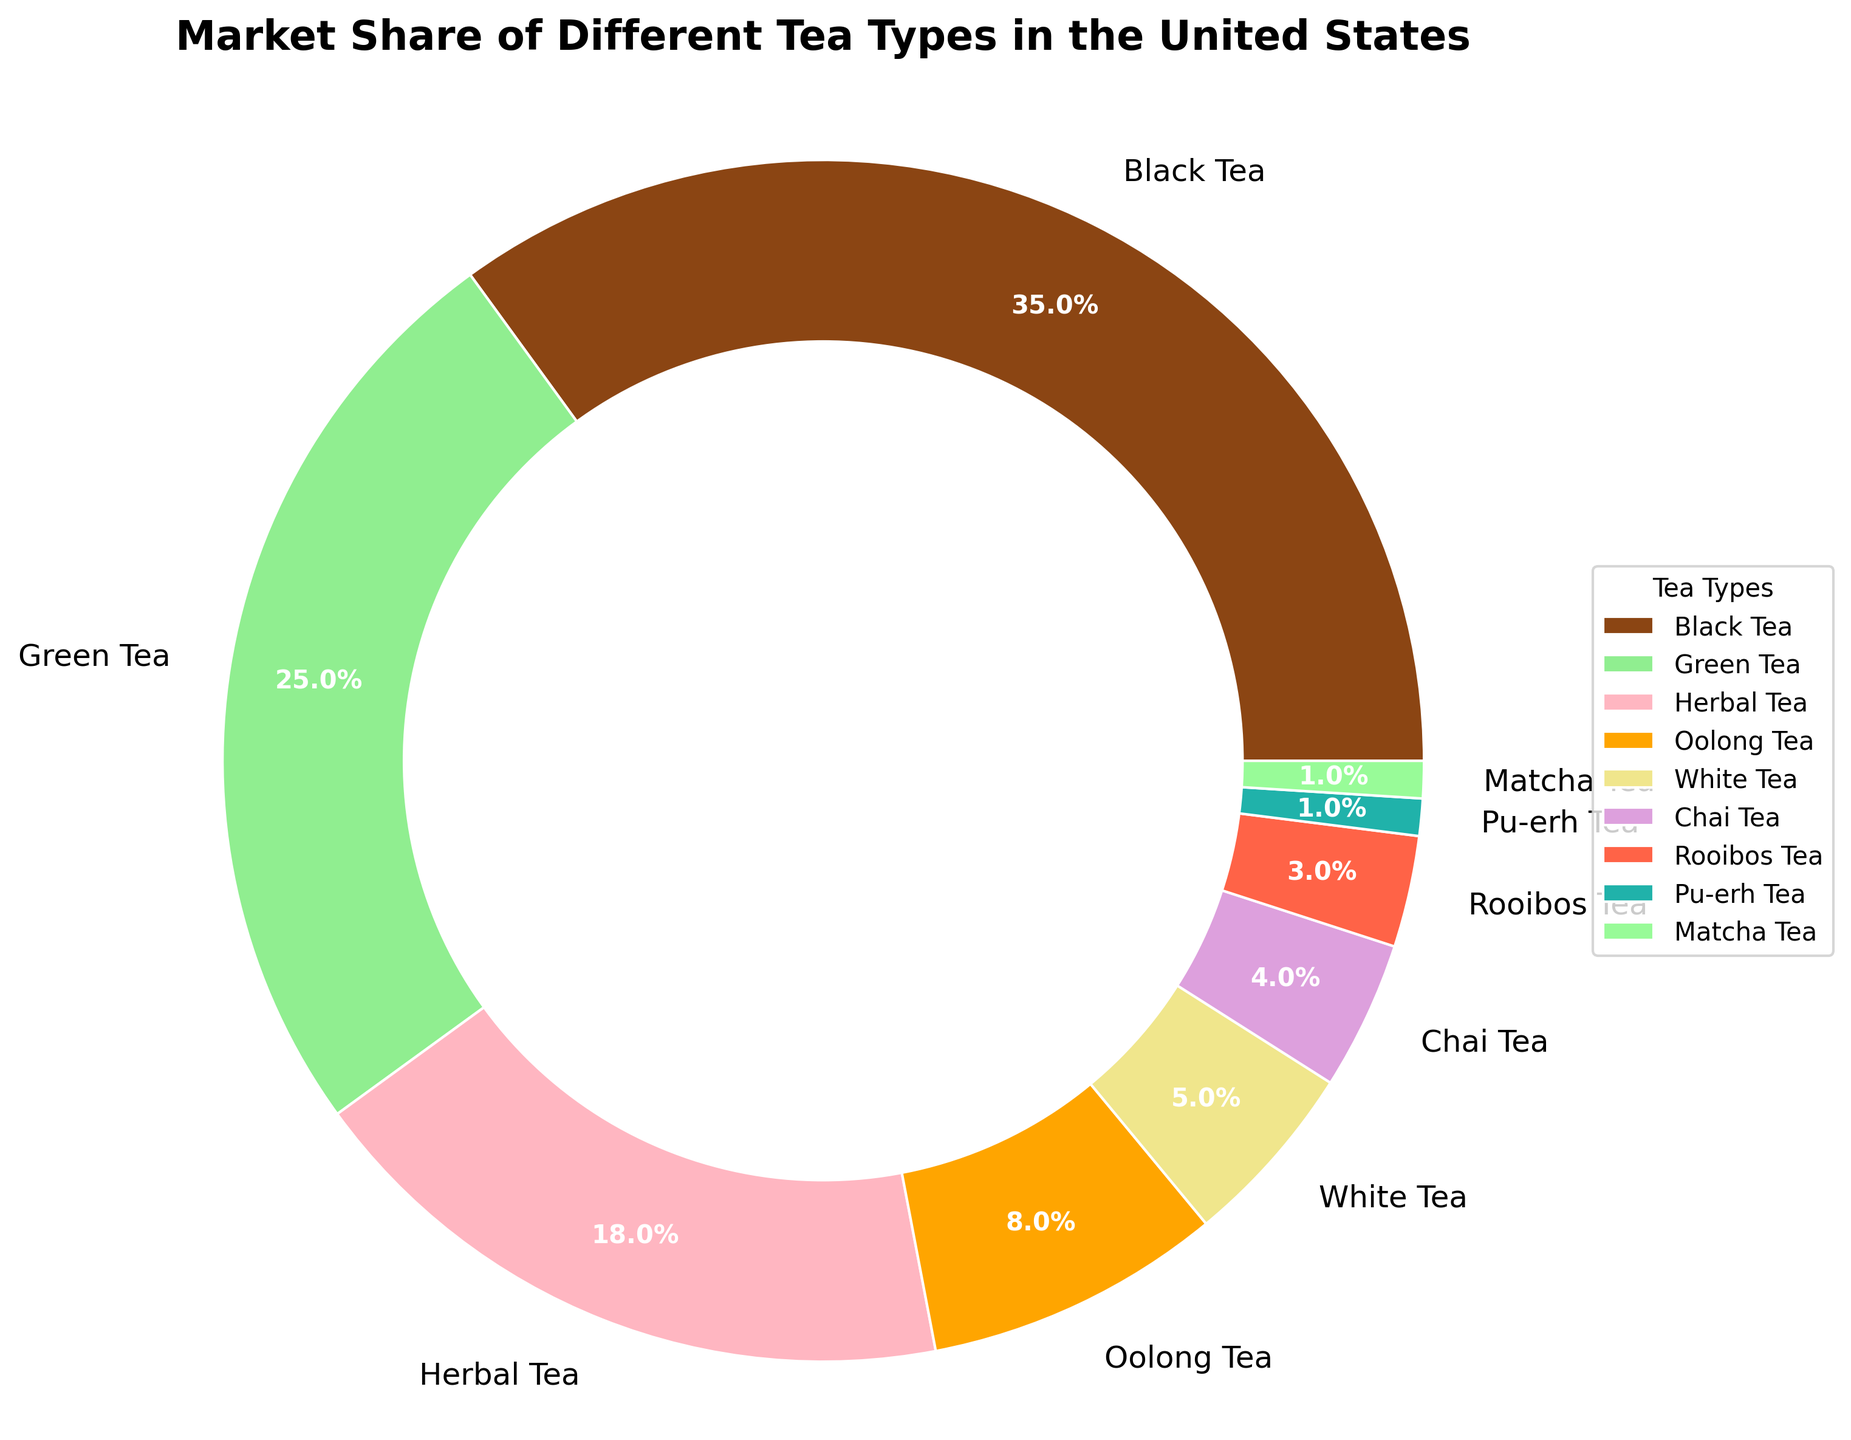What percentage of the market does Green Tea have? Green Tea is labeled with a portion showing its market share as 25% on the pie chart.
Answer: 25% Which tea type has the highest market share, and what is the percentage? By observing the pie chart, we see that Black Tea has the largest portion, labeled as 35%.
Answer: Black Tea, 35% How much more market share does Herbal Tea have compared to Rooibos Tea? Herbal Tea has a market share of 18%, and Rooibos Tea has 3%. The difference is 18% - 3%.
Answer: 15% Combine the market shares of Oolong Tea and White Tea. What is the total percentage? Oolong Tea has 8% and White Tea has 5%. Adding them together gives 8% + 5%.
Answer: 13% Which is the least popular tea type, and what is its market share? The smallest segment is labeled as 1% each for Pu-erh Tea and Matcha Tea, making them the least popular.
Answer: Pu-erh Tea and Matcha Tea, 1% Rank the tea types in order from the highest to the lowest market share. The pie chart shows the market shares as Black Tea (35%), Green Tea (25%), Herbal Tea (18%), Oolong Tea (8%), White Tea (5%), Chai Tea (4%), Rooibos Tea (3%), Pu-erh Tea (1%), and Matcha Tea (1%).
Answer: Black Tea, Green Tea, Herbal Tea, Oolong Tea, White Tea, Chai Tea, Rooibos Tea, Pu-erh Tea, Matcha Tea What is the combined market share of all the teas excluding Black Tea? We exclude the 35% of Black Tea from the total 100%. The remaining market share is 100% - 35%.
Answer: 65% How does the market share of Chai Tea compare to that of Herbal Tea visually? Chai Tea's segment is smaller than Herbal Tea's and is labeled as 4%, while Herbal Tea's segment is 18%.
Answer: Chai Tea has a smaller market share than Herbal Tea If we combine all the "less popular" tea types (those with less than 5% market share), what is their total market share? The less popular teas are White Tea (5%), Chai Tea (4%), Rooibos Tea (3%), Pu-erh Tea (1%), and Matcha Tea (1%). Their combined market share is 5% + 4% + 3% + 1% + 1%.
Answer: 14% 